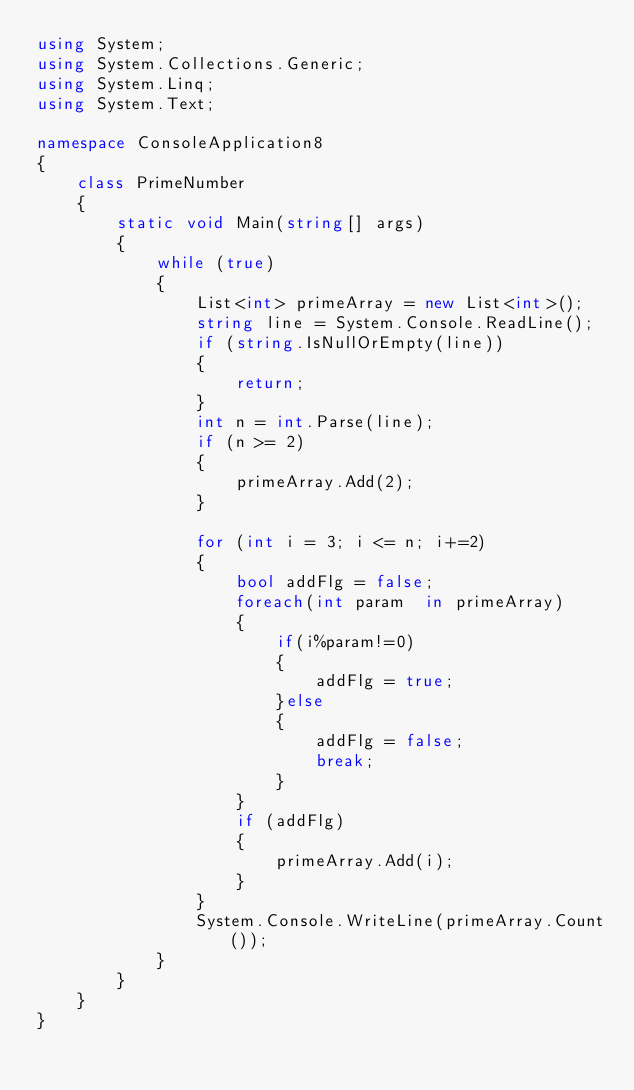Convert code to text. <code><loc_0><loc_0><loc_500><loc_500><_C#_>using System;
using System.Collections.Generic;
using System.Linq;
using System.Text;

namespace ConsoleApplication8
{
    class PrimeNumber
    {
        static void Main(string[] args)
        {
            while (true)
            {
                List<int> primeArray = new List<int>();
                string line = System.Console.ReadLine();
                if (string.IsNullOrEmpty(line))
                {
                    return;
                }
                int n = int.Parse(line);
                if (n >= 2)
                {
                    primeArray.Add(2);
                }

                for (int i = 3; i <= n; i+=2)
                {
                    bool addFlg = false;
                    foreach(int param  in primeArray)
                    {
                        if(i%param!=0)
                        {
                            addFlg = true;
                        }else
                        {
                            addFlg = false;
                            break;
                        }
                    }
                    if (addFlg)
                    {
                        primeArray.Add(i);
                    }
                }
                System.Console.WriteLine(primeArray.Count());
            }
        }
    }
}</code> 